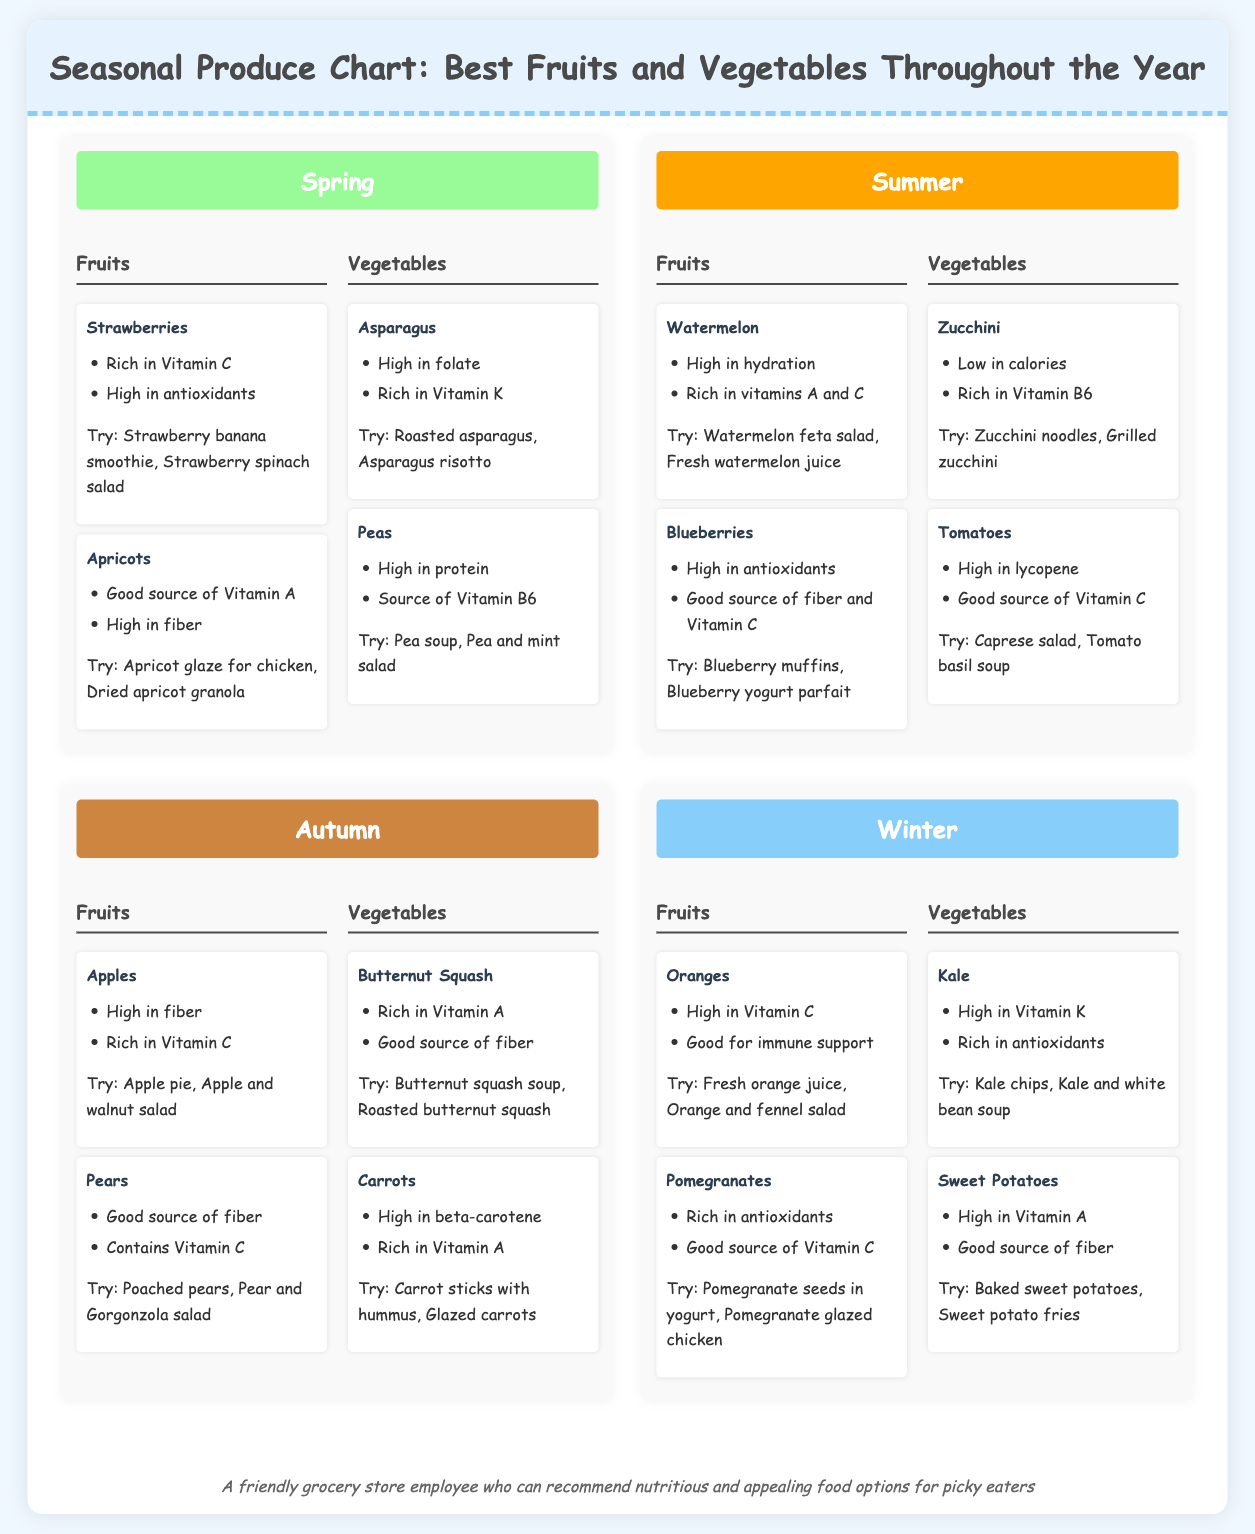what are two fruits listed for spring? The document lists strawberries and apricots as fruits for spring.
Answer: strawberries, apricots which vegetable is highlighted for summer? Zucchini and tomatoes are the vegetables highlighted in summer.
Answer: zucchini, tomatoes how many types of fruits are mentioned for autumn? There are two types of fruits mentioned for autumn: apples and pears.
Answer: 2 what is a recommended dish for using pomegranates? The document suggests using pomegranates to prepare pomegranate seeds in yogurt or pomegranate glazed chicken.
Answer: pomegranate seeds in yogurt which vegetable has the highest Vitamin A content in the winter section? Sweet potatoes are noted for being high in Vitamin A in the winter section.
Answer: Sweet Potatoes list one fruit that is available in winter. The document indicates that oranges are available in winter.
Answer: oranges what health benefit is associated with kale? Kale is high in Vitamin K and rich in antioxidants according to the document.
Answer: high in Vitamin K which season features asparagus? Asparagus is featured in the spring season of the document.
Answer: spring 